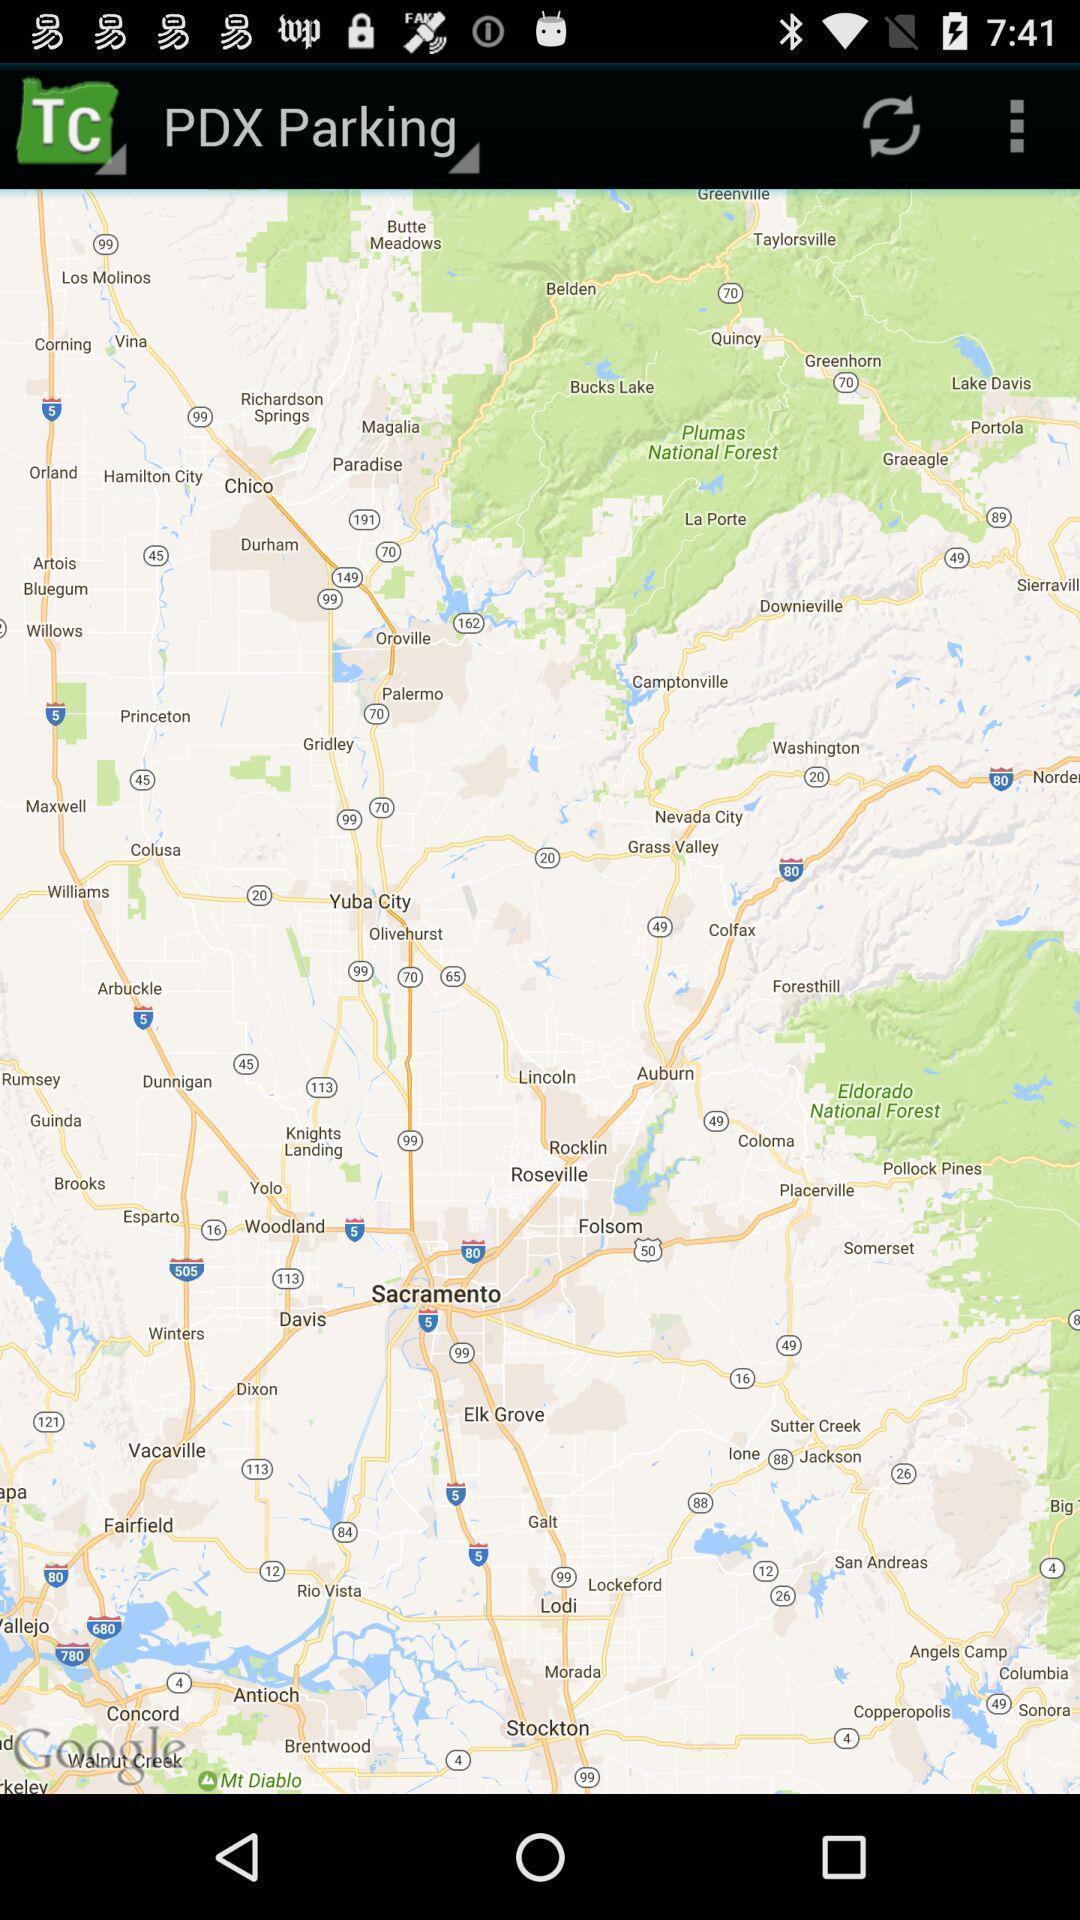Explain what's happening in this screen capture. Page displaying the parking location. 